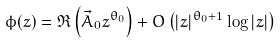Convert formula to latex. <formula><loc_0><loc_0><loc_500><loc_500>\phi ( z ) = \Re \left ( \vec { A } _ { 0 } z ^ { \theta _ { 0 } } \right ) + O \left ( | z | ^ { \theta _ { 0 } + 1 } \log | z | \right )</formula> 